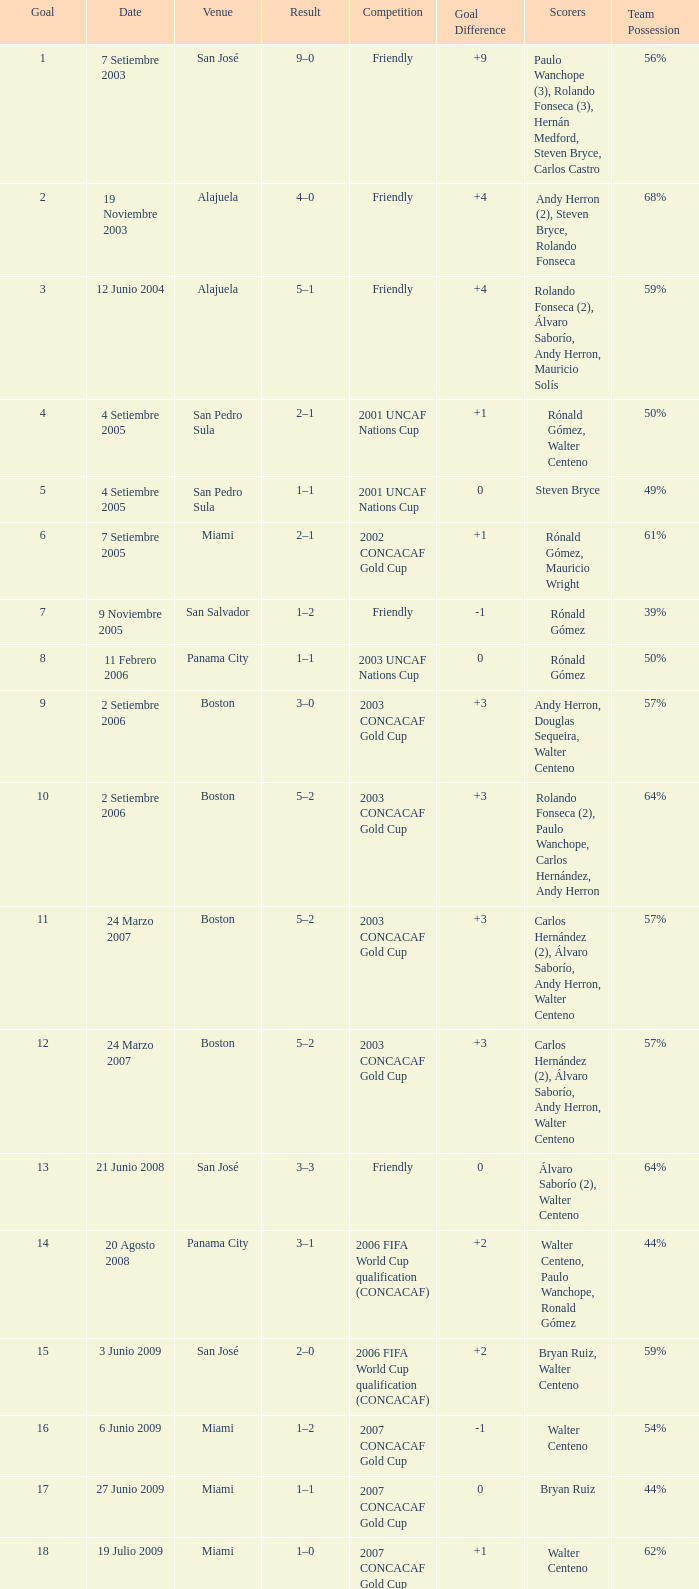Can you give me this table as a dict? {'header': ['Goal', 'Date', 'Venue', 'Result', 'Competition', 'Goal Difference', 'Scorers', 'Team Possession '], 'rows': [['1', '7 Setiembre 2003', 'San José', '9–0', 'Friendly', '+9', 'Paulo Wanchope (3), Rolando Fonseca (3), Hernán Medford, Steven Bryce, Carlos Castro', '56%'], ['2', '19 Noviembre 2003', 'Alajuela', '4–0', 'Friendly', '+4', 'Andy Herron (2), Steven Bryce, Rolando Fonseca', '68%'], ['3', '12 Junio 2004', 'Alajuela', '5–1', 'Friendly', '+4', 'Rolando Fonseca (2), Álvaro Saborío, Andy Herron, Mauricio Solís', '59%'], ['4', '4 Setiembre 2005', 'San Pedro Sula', '2–1', '2001 UNCAF Nations Cup', '+1', 'Rónald Gómez, Walter Centeno', '50%'], ['5', '4 Setiembre 2005', 'San Pedro Sula', '1–1', '2001 UNCAF Nations Cup', '0', 'Steven Bryce', '49%'], ['6', '7 Setiembre 2005', 'Miami', '2–1', '2002 CONCACAF Gold Cup', '+1', 'Rónald Gómez, Mauricio Wright', '61%'], ['7', '9 Noviembre 2005', 'San Salvador', '1–2', 'Friendly', '-1', 'Rónald Gómez', '39%'], ['8', '11 Febrero 2006', 'Panama City', '1–1', '2003 UNCAF Nations Cup', '0', 'Rónald Gómez', '50%'], ['9', '2 Setiembre 2006', 'Boston', '3–0', '2003 CONCACAF Gold Cup', '+3', 'Andy Herron, Douglas Sequeira, Walter Centeno', '57%'], ['10', '2 Setiembre 2006', 'Boston', '5–2', '2003 CONCACAF Gold Cup', '+3', 'Rolando Fonseca (2), Paulo Wanchope, Carlos Hernández, Andy Herron', '64%'], ['11', '24 Marzo 2007', 'Boston', '5–2', '2003 CONCACAF Gold Cup', '+3', 'Carlos Hernández (2), Álvaro Saborío, Andy Herron, Walter Centeno', '57%'], ['12', '24 Marzo 2007', 'Boston', '5–2', '2003 CONCACAF Gold Cup', '+3', 'Carlos Hernández (2), Álvaro Saborío, Andy Herron, Walter Centeno', '57%'], ['13', '21 Junio 2008', 'San José', '3–3', 'Friendly', '0', 'Álvaro Saborío (2), Walter Centeno', '64%'], ['14', '20 Agosto 2008', 'Panama City', '3–1', '2006 FIFA World Cup qualification (CONCACAF)', '+2', 'Walter Centeno, Paulo Wanchope, Ronald Gómez', '44%'], ['15', '3 Junio 2009', 'San José', '2–0', '2006 FIFA World Cup qualification (CONCACAF)', '+2', 'Bryan Ruiz, Walter Centeno', '59%'], ['16', '6 Junio 2009', 'Miami', '1–2', '2007 CONCACAF Gold Cup', '-1', 'Walter Centeno', '54%'], ['17', '27 Junio 2009', 'Miami', '1–1', '2007 CONCACAF Gold Cup', '0', 'Bryan Ruiz', '44%'], ['18', '19 Julio 2009', 'Miami', '1–0', '2007 CONCACAF Gold Cup', '+1', 'Walter Centeno', '62%'], ['19', '18 octubre 2007', 'San José', '1–1', 'Friendly', '0', 'Álvaro Saborío', '48%'], ['20', '19 Julio 2009', 'Paramaribo', '4–1', '2010 FIFA World Cup qualification (CONCACAF)', '+3', 'Álvaro Saborío (2), Cristian Bolaños, Michael Umaña', '49%'], ['21', '3 Junio 2009', 'San José', '1–0', '2010 FIFA World Cup qualification (CONCACAF)', '+1', 'Bryan Ruiz', '54%'], ['22', '6 Junio 2009', 'Florida', '2–2', '2009 CONCACAF Gold Cup', '0', 'Celso Borges, Pablo Herrera', '53%'], ['23', '27 Junio 2009', 'San José', '4–0', '2010 FIFA World Cup qualification (CONCACAF)', '+4', 'Álvaro Saborío (2), Walter Centeno, Celso Borges', '62%'], ['24', '19 Julio 2009', 'Montevideo', '1–1', '2010 FIFA World Cup qualification (CONCACAF)', '0', 'Walter Centeno', '34%']]} How was the competition in which 6 goals were made? 2002 CONCACAF Gold Cup. 